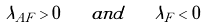<formula> <loc_0><loc_0><loc_500><loc_500>\lambda _ { A F } > 0 \quad a n d \quad \lambda _ { F } < 0</formula> 